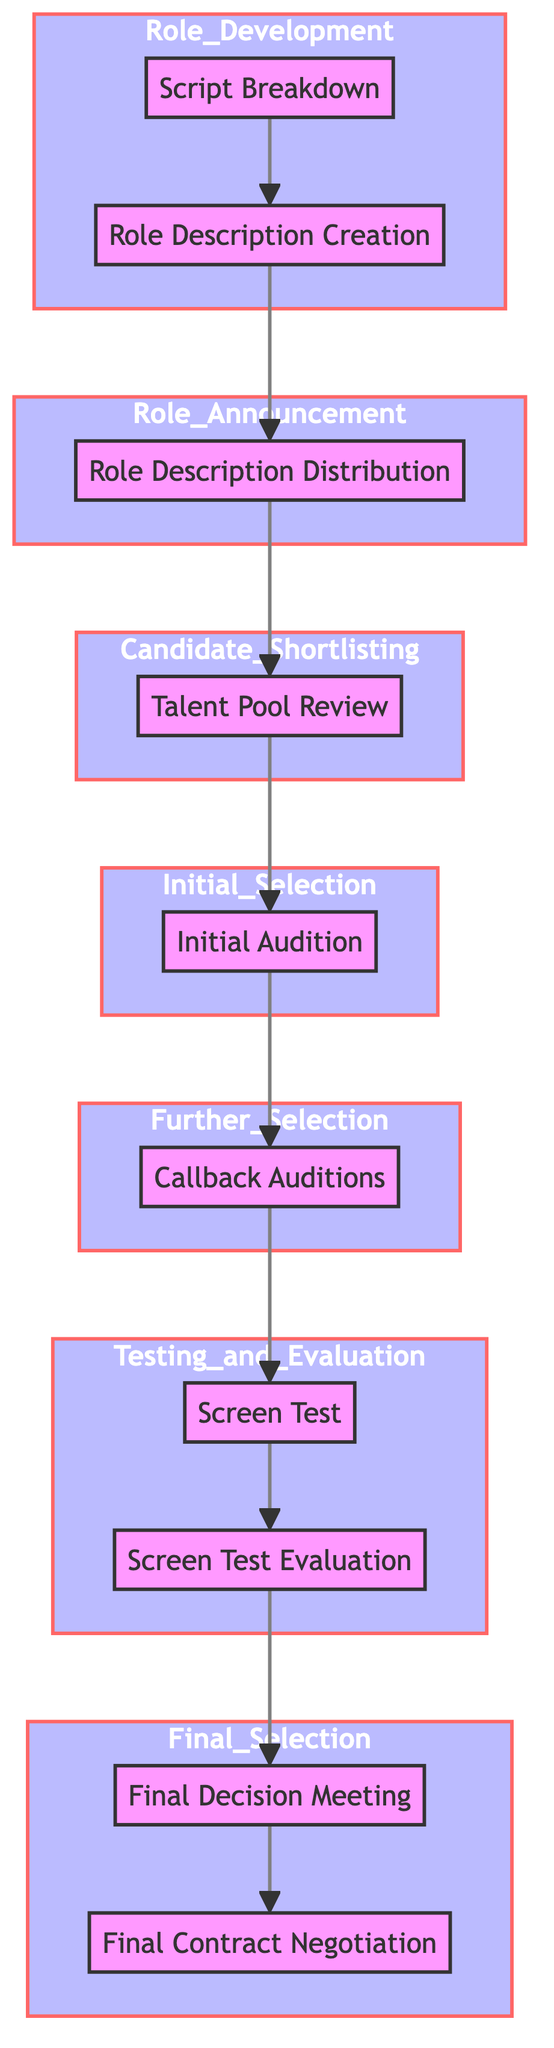What is the first step in the casting process? The first step in the casting process is “Script Breakdown,” which identifies and lists all roles to be cast from the script.
Answer: Script Breakdown How many stages are there in the casting process? There are seven stages in the casting process: Role Development, Role Announcement, Candidate Shortlisting, Initial Selection, Further Selection, Testing and Evaluation, and Final Selection.
Answer: Seven Which node follows "Initial Audition"? The node that follows "Initial Audition" is "Callback Auditions," which invites selected actors for additional readings or improvisation tests.
Answer: Callback Auditions What is the final step in the casting process? The final step in the casting process is "Final Contract Negotiation," where the contract details, salary, and perks are finalized with the selected candidate.
Answer: Final Contract Negotiation In which stage does "Screen Test Evaluation" occur? "Screen Test Evaluation" occurs in the "Testing and Evaluation" stage, which includes assessing the performance during screen tests.
Answer: Testing and Evaluation How many nodes are between "Role Description Creation" and "Screen Test"? There are four nodes between "Role Description Creation" and "Screen Test": "Role Description Distribution," "Talent Pool Review," "Initial Audition," and "Callback Auditions."
Answer: Four What action occurs immediately before "Final Decision Meeting"? The action that occurs immediately before "Final Decision Meeting" is "Screen Test Evaluation," where the performances during screen tests are assessed.
Answer: Screen Test Evaluation Which two nodes are the last in the "Final Selection" stage? The last two nodes in the "Final Selection" stage are "Final Decision Meeting" and "Final Contract Negotiation."
Answer: Final Decision Meeting, Final Contract Negotiation What is shared in the "Role Description Distribution"? In the "Role Description Distribution,” role requirements are shared with talent agencies and industry networks.
Answer: Role requirements 